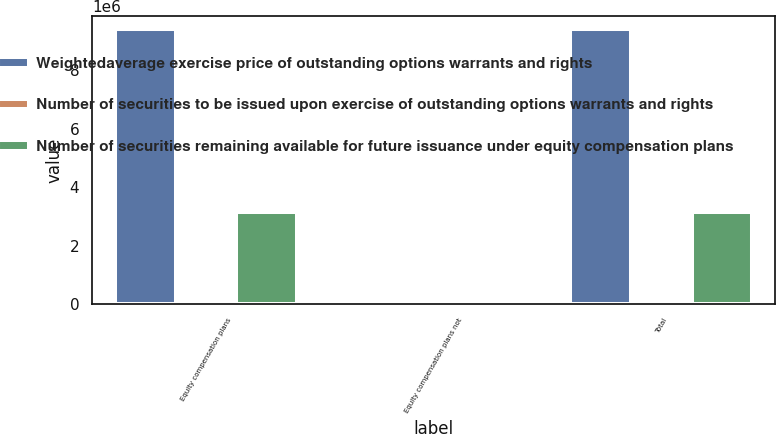<chart> <loc_0><loc_0><loc_500><loc_500><stacked_bar_chart><ecel><fcel>Equity compensation plans<fcel>Equity compensation plans not<fcel>Total<nl><fcel>Weightedaverage exercise price of outstanding options warrants and rights<fcel>9.39392e+06<fcel>0<fcel>9.39392e+06<nl><fcel>Number of securities to be issued upon exercise of outstanding options warrants and rights<fcel>51.8<fcel>0<fcel>51.8<nl><fcel>Number of securities remaining available for future issuance under equity compensation plans<fcel>3.136e+06<fcel>0<fcel>3.136e+06<nl></chart> 